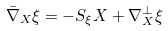<formula> <loc_0><loc_0><loc_500><loc_500>\bar { \nabla } _ { X } \xi = - S _ { \xi } X + \nabla ^ { \perp } _ { X } \xi</formula> 